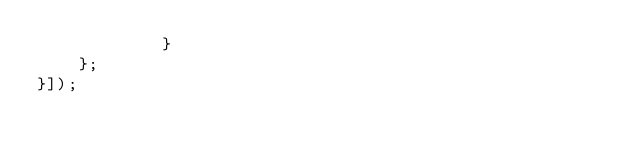<code> <loc_0><loc_0><loc_500><loc_500><_JavaScript_>            }
    };
}]);
</code> 